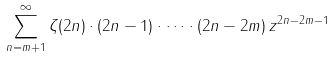Convert formula to latex. <formula><loc_0><loc_0><loc_500><loc_500>\sum _ { n = m + 1 } ^ { \infty } { \zeta { ( 2 n ) } \cdot ( 2 n - 1 ) \cdot \dots \cdot ( 2 n - 2 m ) \, z ^ { 2 n - 2 m - 1 } }</formula> 